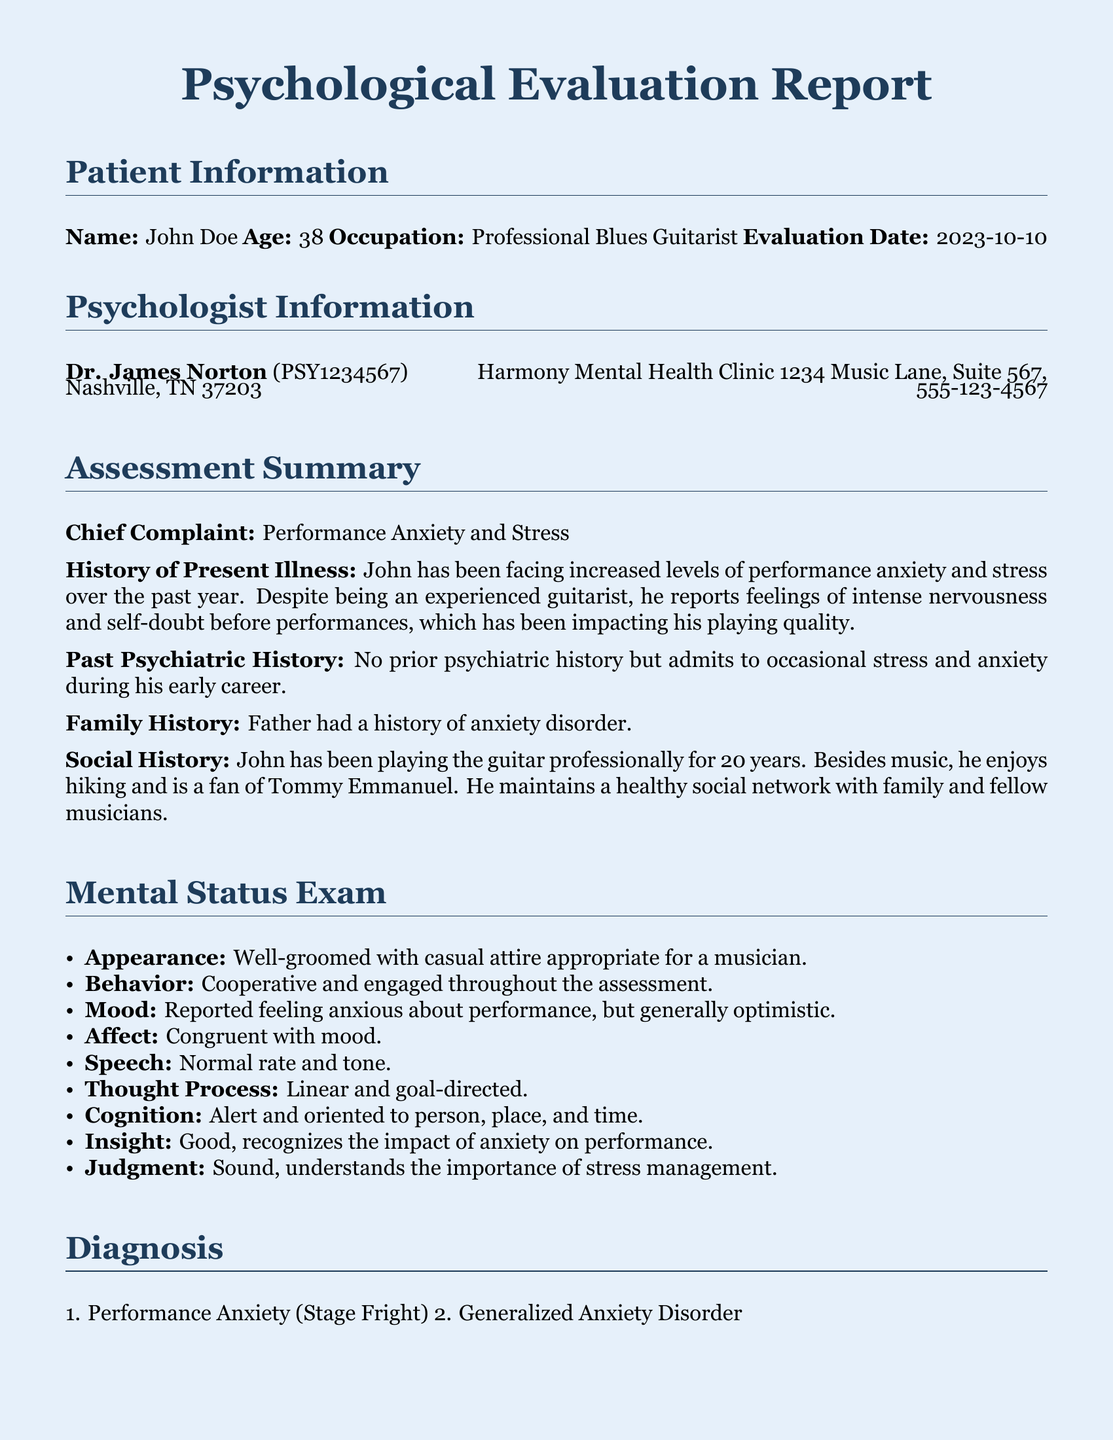What is the patient's name? The patient's name is explicitly stated in the document under Patient Information.
Answer: John Doe What is the age of the patient? The age of the patient is listed alongside their name in Patient Information.
Answer: 38 Who conducted the psychological evaluation? The psychologist's name is mentioned in the Psychologist Information section.
Answer: Dr. James Norton What is the chief complaint of the patient? The chief complaint is detailed in the Assessment Summary section of the report.
Answer: Performance Anxiety and Stress What therapy is recommended for addressing negative thought patterns? The recommendations in the document include various techniques for managing stress, one of which addresses negative thought patterns.
Answer: Cognitive Behavioral Therapy (CBT) What is the short-term goal for the treatment plan? The treatment plan specifies a measurable short-term goal in the associated section.
Answer: Reduce pre-performance anxiety by 50% in 3 months What is one of the hobbies of the patient? The social history provides insights into the patient's life outside of music, indicating a specific interest.
Answer: Hiking How often are the follow-up therapy sessions scheduled? The follow-up plan outlines the frequency of therapy sessions.
Answer: Bi-weekly What aspect of the patient's family history is noted? The document mentions a specific concern regarding family history in the Family History section.
Answer: Father had a history of anxiety disorder 